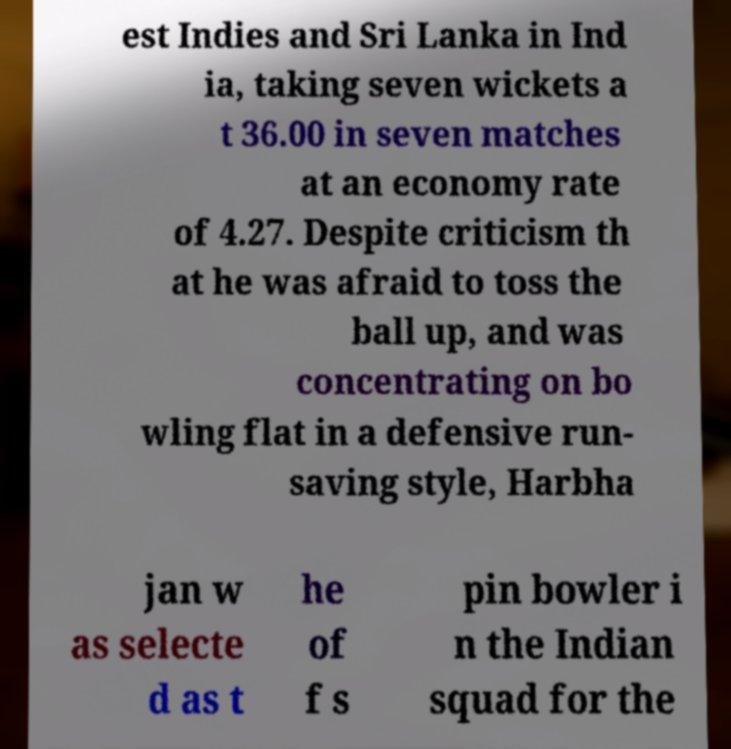Can you accurately transcribe the text from the provided image for me? est Indies and Sri Lanka in Ind ia, taking seven wickets a t 36.00 in seven matches at an economy rate of 4.27. Despite criticism th at he was afraid to toss the ball up, and was concentrating on bo wling flat in a defensive run- saving style, Harbha jan w as selecte d as t he of f s pin bowler i n the Indian squad for the 